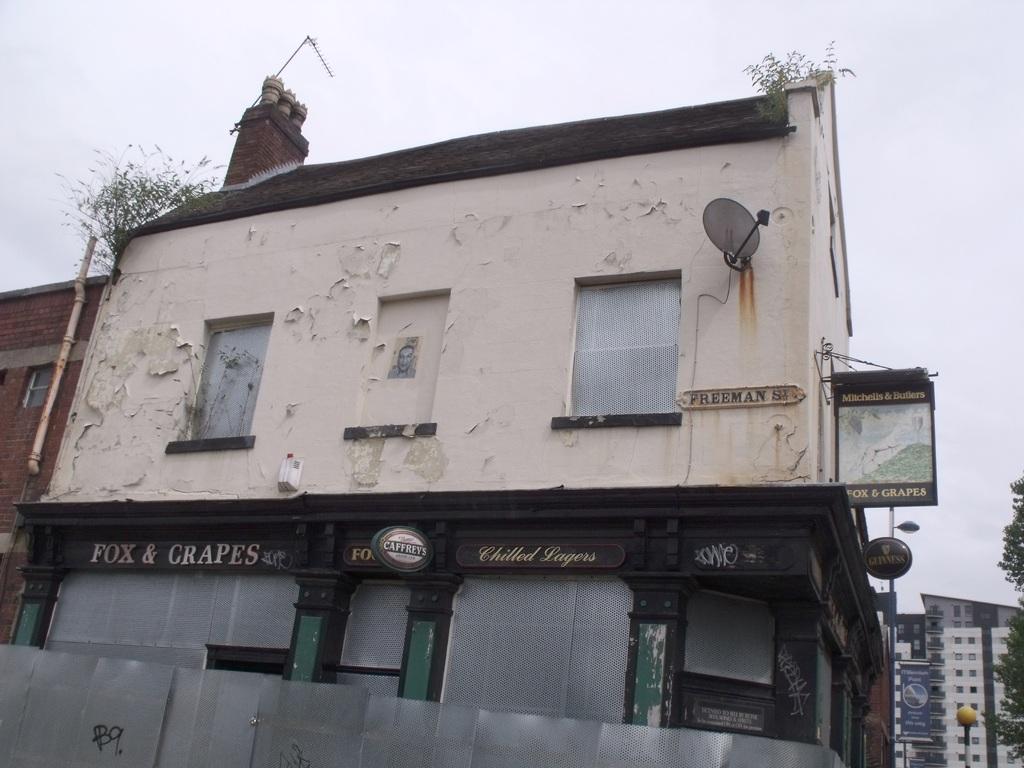Can you describe this image briefly? Here we can see a building,windows,antenna on the wall,plants on the building,roof,hoardings,pipe on the wall and at the bottom there is a metal sheet and name boards on the wall. On the left we can see buildings,windows,poles,trees and hoardings. In the background we can see the sky. 